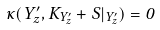Convert formula to latex. <formula><loc_0><loc_0><loc_500><loc_500>\kappa ( Y ^ { \prime } _ { z } , K _ { Y ^ { \prime } _ { z } } + S | _ { Y ^ { \prime } _ { z } } ) = 0</formula> 